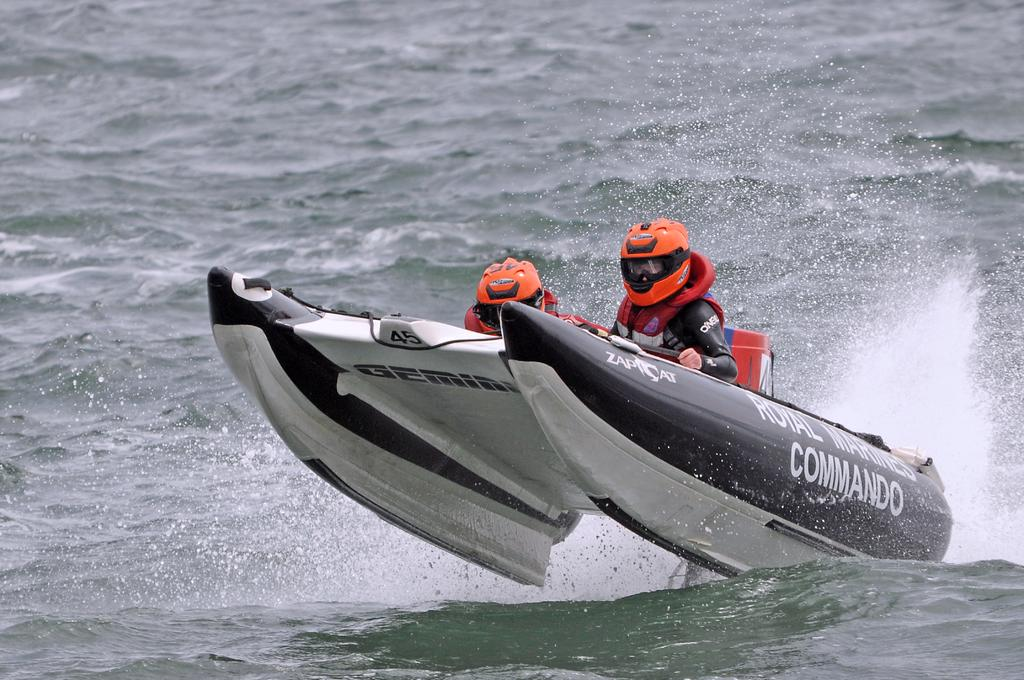Provide a one-sentence caption for the provided image. Two people in orange helmets are at the front of a boat with the word Commando on the side. 